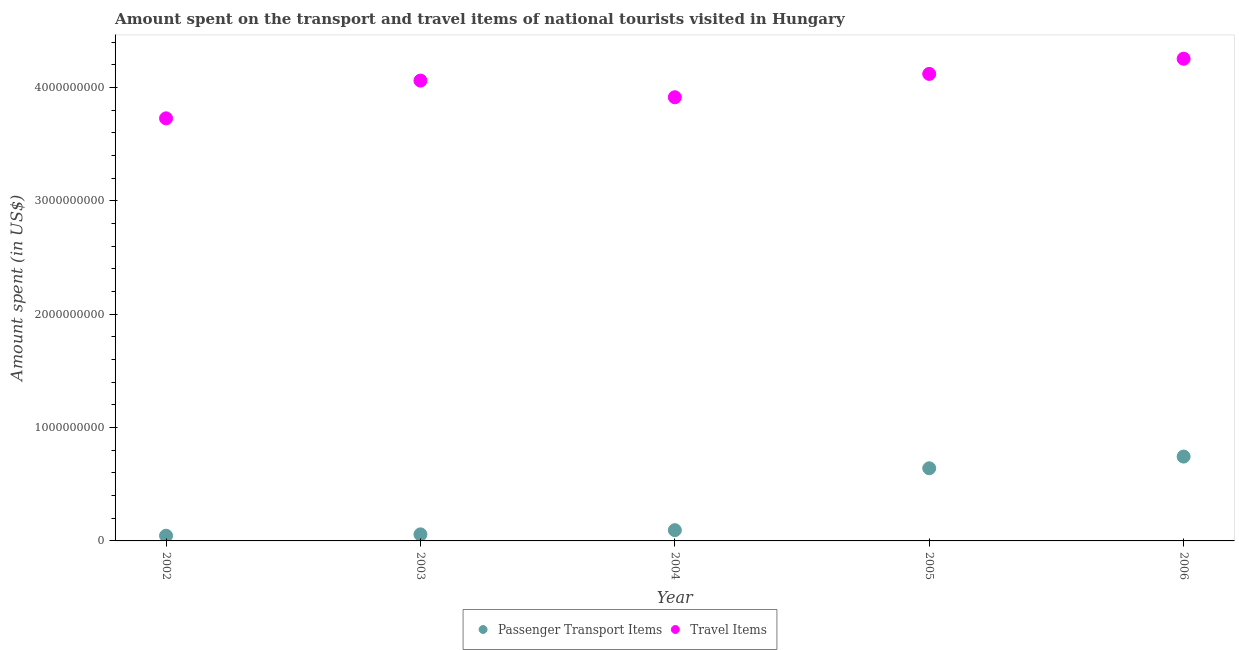What is the amount spent in travel items in 2004?
Your answer should be very brief. 3.91e+09. Across all years, what is the maximum amount spent in travel items?
Give a very brief answer. 4.25e+09. Across all years, what is the minimum amount spent on passenger transport items?
Your answer should be very brief. 4.60e+07. In which year was the amount spent in travel items maximum?
Offer a terse response. 2006. In which year was the amount spent on passenger transport items minimum?
Keep it short and to the point. 2002. What is the total amount spent on passenger transport items in the graph?
Offer a terse response. 1.58e+09. What is the difference between the amount spent on passenger transport items in 2003 and that in 2005?
Your response must be concise. -5.83e+08. What is the difference between the amount spent on passenger transport items in 2006 and the amount spent in travel items in 2005?
Your answer should be very brief. -3.38e+09. What is the average amount spent on passenger transport items per year?
Offer a very short reply. 3.17e+08. In the year 2006, what is the difference between the amount spent in travel items and amount spent on passenger transport items?
Keep it short and to the point. 3.51e+09. In how many years, is the amount spent in travel items greater than 1600000000 US$?
Provide a succinct answer. 5. What is the ratio of the amount spent in travel items in 2003 to that in 2005?
Your answer should be compact. 0.99. Is the difference between the amount spent in travel items in 2002 and 2005 greater than the difference between the amount spent on passenger transport items in 2002 and 2005?
Provide a succinct answer. Yes. What is the difference between the highest and the second highest amount spent on passenger transport items?
Make the answer very short. 1.03e+08. What is the difference between the highest and the lowest amount spent on passenger transport items?
Keep it short and to the point. 6.98e+08. In how many years, is the amount spent in travel items greater than the average amount spent in travel items taken over all years?
Offer a very short reply. 3. Is the amount spent on passenger transport items strictly greater than the amount spent in travel items over the years?
Offer a very short reply. No. How many dotlines are there?
Provide a succinct answer. 2. What is the difference between two consecutive major ticks on the Y-axis?
Provide a succinct answer. 1.00e+09. Are the values on the major ticks of Y-axis written in scientific E-notation?
Provide a short and direct response. No. Does the graph contain any zero values?
Your answer should be compact. No. What is the title of the graph?
Ensure brevity in your answer.  Amount spent on the transport and travel items of national tourists visited in Hungary. Does "Non-resident workers" appear as one of the legend labels in the graph?
Make the answer very short. No. What is the label or title of the X-axis?
Offer a very short reply. Year. What is the label or title of the Y-axis?
Make the answer very short. Amount spent (in US$). What is the Amount spent (in US$) of Passenger Transport Items in 2002?
Your answer should be very brief. 4.60e+07. What is the Amount spent (in US$) of Travel Items in 2002?
Offer a very short reply. 3.73e+09. What is the Amount spent (in US$) in Passenger Transport Items in 2003?
Offer a very short reply. 5.80e+07. What is the Amount spent (in US$) in Travel Items in 2003?
Provide a succinct answer. 4.06e+09. What is the Amount spent (in US$) in Passenger Transport Items in 2004?
Your answer should be very brief. 9.50e+07. What is the Amount spent (in US$) of Travel Items in 2004?
Your response must be concise. 3.91e+09. What is the Amount spent (in US$) of Passenger Transport Items in 2005?
Make the answer very short. 6.41e+08. What is the Amount spent (in US$) in Travel Items in 2005?
Your answer should be very brief. 4.12e+09. What is the Amount spent (in US$) in Passenger Transport Items in 2006?
Give a very brief answer. 7.44e+08. What is the Amount spent (in US$) in Travel Items in 2006?
Keep it short and to the point. 4.25e+09. Across all years, what is the maximum Amount spent (in US$) of Passenger Transport Items?
Keep it short and to the point. 7.44e+08. Across all years, what is the maximum Amount spent (in US$) in Travel Items?
Your answer should be compact. 4.25e+09. Across all years, what is the minimum Amount spent (in US$) of Passenger Transport Items?
Your answer should be compact. 4.60e+07. Across all years, what is the minimum Amount spent (in US$) in Travel Items?
Your answer should be very brief. 3.73e+09. What is the total Amount spent (in US$) of Passenger Transport Items in the graph?
Keep it short and to the point. 1.58e+09. What is the total Amount spent (in US$) in Travel Items in the graph?
Your response must be concise. 2.01e+1. What is the difference between the Amount spent (in US$) of Passenger Transport Items in 2002 and that in 2003?
Keep it short and to the point. -1.20e+07. What is the difference between the Amount spent (in US$) in Travel Items in 2002 and that in 2003?
Ensure brevity in your answer.  -3.33e+08. What is the difference between the Amount spent (in US$) in Passenger Transport Items in 2002 and that in 2004?
Provide a succinct answer. -4.90e+07. What is the difference between the Amount spent (in US$) of Travel Items in 2002 and that in 2004?
Your answer should be compact. -1.86e+08. What is the difference between the Amount spent (in US$) of Passenger Transport Items in 2002 and that in 2005?
Your answer should be compact. -5.95e+08. What is the difference between the Amount spent (in US$) of Travel Items in 2002 and that in 2005?
Provide a short and direct response. -3.92e+08. What is the difference between the Amount spent (in US$) in Passenger Transport Items in 2002 and that in 2006?
Your answer should be very brief. -6.98e+08. What is the difference between the Amount spent (in US$) in Travel Items in 2002 and that in 2006?
Give a very brief answer. -5.26e+08. What is the difference between the Amount spent (in US$) in Passenger Transport Items in 2003 and that in 2004?
Provide a succinct answer. -3.70e+07. What is the difference between the Amount spent (in US$) of Travel Items in 2003 and that in 2004?
Your response must be concise. 1.47e+08. What is the difference between the Amount spent (in US$) of Passenger Transport Items in 2003 and that in 2005?
Make the answer very short. -5.83e+08. What is the difference between the Amount spent (in US$) of Travel Items in 2003 and that in 2005?
Make the answer very short. -5.90e+07. What is the difference between the Amount spent (in US$) in Passenger Transport Items in 2003 and that in 2006?
Ensure brevity in your answer.  -6.86e+08. What is the difference between the Amount spent (in US$) of Travel Items in 2003 and that in 2006?
Offer a very short reply. -1.93e+08. What is the difference between the Amount spent (in US$) in Passenger Transport Items in 2004 and that in 2005?
Your answer should be compact. -5.46e+08. What is the difference between the Amount spent (in US$) of Travel Items in 2004 and that in 2005?
Provide a short and direct response. -2.06e+08. What is the difference between the Amount spent (in US$) of Passenger Transport Items in 2004 and that in 2006?
Offer a very short reply. -6.49e+08. What is the difference between the Amount spent (in US$) in Travel Items in 2004 and that in 2006?
Your response must be concise. -3.40e+08. What is the difference between the Amount spent (in US$) of Passenger Transport Items in 2005 and that in 2006?
Provide a short and direct response. -1.03e+08. What is the difference between the Amount spent (in US$) of Travel Items in 2005 and that in 2006?
Your response must be concise. -1.34e+08. What is the difference between the Amount spent (in US$) of Passenger Transport Items in 2002 and the Amount spent (in US$) of Travel Items in 2003?
Your answer should be very brief. -4.02e+09. What is the difference between the Amount spent (in US$) in Passenger Transport Items in 2002 and the Amount spent (in US$) in Travel Items in 2004?
Make the answer very short. -3.87e+09. What is the difference between the Amount spent (in US$) of Passenger Transport Items in 2002 and the Amount spent (in US$) of Travel Items in 2005?
Your answer should be compact. -4.07e+09. What is the difference between the Amount spent (in US$) of Passenger Transport Items in 2002 and the Amount spent (in US$) of Travel Items in 2006?
Make the answer very short. -4.21e+09. What is the difference between the Amount spent (in US$) in Passenger Transport Items in 2003 and the Amount spent (in US$) in Travel Items in 2004?
Your answer should be compact. -3.86e+09. What is the difference between the Amount spent (in US$) in Passenger Transport Items in 2003 and the Amount spent (in US$) in Travel Items in 2005?
Your response must be concise. -4.06e+09. What is the difference between the Amount spent (in US$) of Passenger Transport Items in 2003 and the Amount spent (in US$) of Travel Items in 2006?
Your answer should be very brief. -4.20e+09. What is the difference between the Amount spent (in US$) in Passenger Transport Items in 2004 and the Amount spent (in US$) in Travel Items in 2005?
Your answer should be compact. -4.02e+09. What is the difference between the Amount spent (in US$) of Passenger Transport Items in 2004 and the Amount spent (in US$) of Travel Items in 2006?
Ensure brevity in your answer.  -4.16e+09. What is the difference between the Amount spent (in US$) in Passenger Transport Items in 2005 and the Amount spent (in US$) in Travel Items in 2006?
Ensure brevity in your answer.  -3.61e+09. What is the average Amount spent (in US$) in Passenger Transport Items per year?
Offer a very short reply. 3.17e+08. What is the average Amount spent (in US$) of Travel Items per year?
Provide a succinct answer. 4.02e+09. In the year 2002, what is the difference between the Amount spent (in US$) in Passenger Transport Items and Amount spent (in US$) in Travel Items?
Your response must be concise. -3.68e+09. In the year 2003, what is the difference between the Amount spent (in US$) in Passenger Transport Items and Amount spent (in US$) in Travel Items?
Your answer should be very brief. -4.00e+09. In the year 2004, what is the difference between the Amount spent (in US$) in Passenger Transport Items and Amount spent (in US$) in Travel Items?
Make the answer very short. -3.82e+09. In the year 2005, what is the difference between the Amount spent (in US$) in Passenger Transport Items and Amount spent (in US$) in Travel Items?
Give a very brief answer. -3.48e+09. In the year 2006, what is the difference between the Amount spent (in US$) in Passenger Transport Items and Amount spent (in US$) in Travel Items?
Your answer should be compact. -3.51e+09. What is the ratio of the Amount spent (in US$) in Passenger Transport Items in 2002 to that in 2003?
Your response must be concise. 0.79. What is the ratio of the Amount spent (in US$) of Travel Items in 2002 to that in 2003?
Offer a terse response. 0.92. What is the ratio of the Amount spent (in US$) of Passenger Transport Items in 2002 to that in 2004?
Give a very brief answer. 0.48. What is the ratio of the Amount spent (in US$) in Travel Items in 2002 to that in 2004?
Your response must be concise. 0.95. What is the ratio of the Amount spent (in US$) of Passenger Transport Items in 2002 to that in 2005?
Offer a terse response. 0.07. What is the ratio of the Amount spent (in US$) of Travel Items in 2002 to that in 2005?
Offer a terse response. 0.9. What is the ratio of the Amount spent (in US$) in Passenger Transport Items in 2002 to that in 2006?
Your response must be concise. 0.06. What is the ratio of the Amount spent (in US$) of Travel Items in 2002 to that in 2006?
Offer a very short reply. 0.88. What is the ratio of the Amount spent (in US$) in Passenger Transport Items in 2003 to that in 2004?
Offer a very short reply. 0.61. What is the ratio of the Amount spent (in US$) in Travel Items in 2003 to that in 2004?
Ensure brevity in your answer.  1.04. What is the ratio of the Amount spent (in US$) of Passenger Transport Items in 2003 to that in 2005?
Provide a succinct answer. 0.09. What is the ratio of the Amount spent (in US$) in Travel Items in 2003 to that in 2005?
Your response must be concise. 0.99. What is the ratio of the Amount spent (in US$) in Passenger Transport Items in 2003 to that in 2006?
Ensure brevity in your answer.  0.08. What is the ratio of the Amount spent (in US$) of Travel Items in 2003 to that in 2006?
Offer a terse response. 0.95. What is the ratio of the Amount spent (in US$) in Passenger Transport Items in 2004 to that in 2005?
Make the answer very short. 0.15. What is the ratio of the Amount spent (in US$) in Passenger Transport Items in 2004 to that in 2006?
Your response must be concise. 0.13. What is the ratio of the Amount spent (in US$) of Travel Items in 2004 to that in 2006?
Provide a short and direct response. 0.92. What is the ratio of the Amount spent (in US$) in Passenger Transport Items in 2005 to that in 2006?
Provide a short and direct response. 0.86. What is the ratio of the Amount spent (in US$) in Travel Items in 2005 to that in 2006?
Offer a terse response. 0.97. What is the difference between the highest and the second highest Amount spent (in US$) of Passenger Transport Items?
Give a very brief answer. 1.03e+08. What is the difference between the highest and the second highest Amount spent (in US$) in Travel Items?
Offer a terse response. 1.34e+08. What is the difference between the highest and the lowest Amount spent (in US$) in Passenger Transport Items?
Make the answer very short. 6.98e+08. What is the difference between the highest and the lowest Amount spent (in US$) in Travel Items?
Offer a terse response. 5.26e+08. 